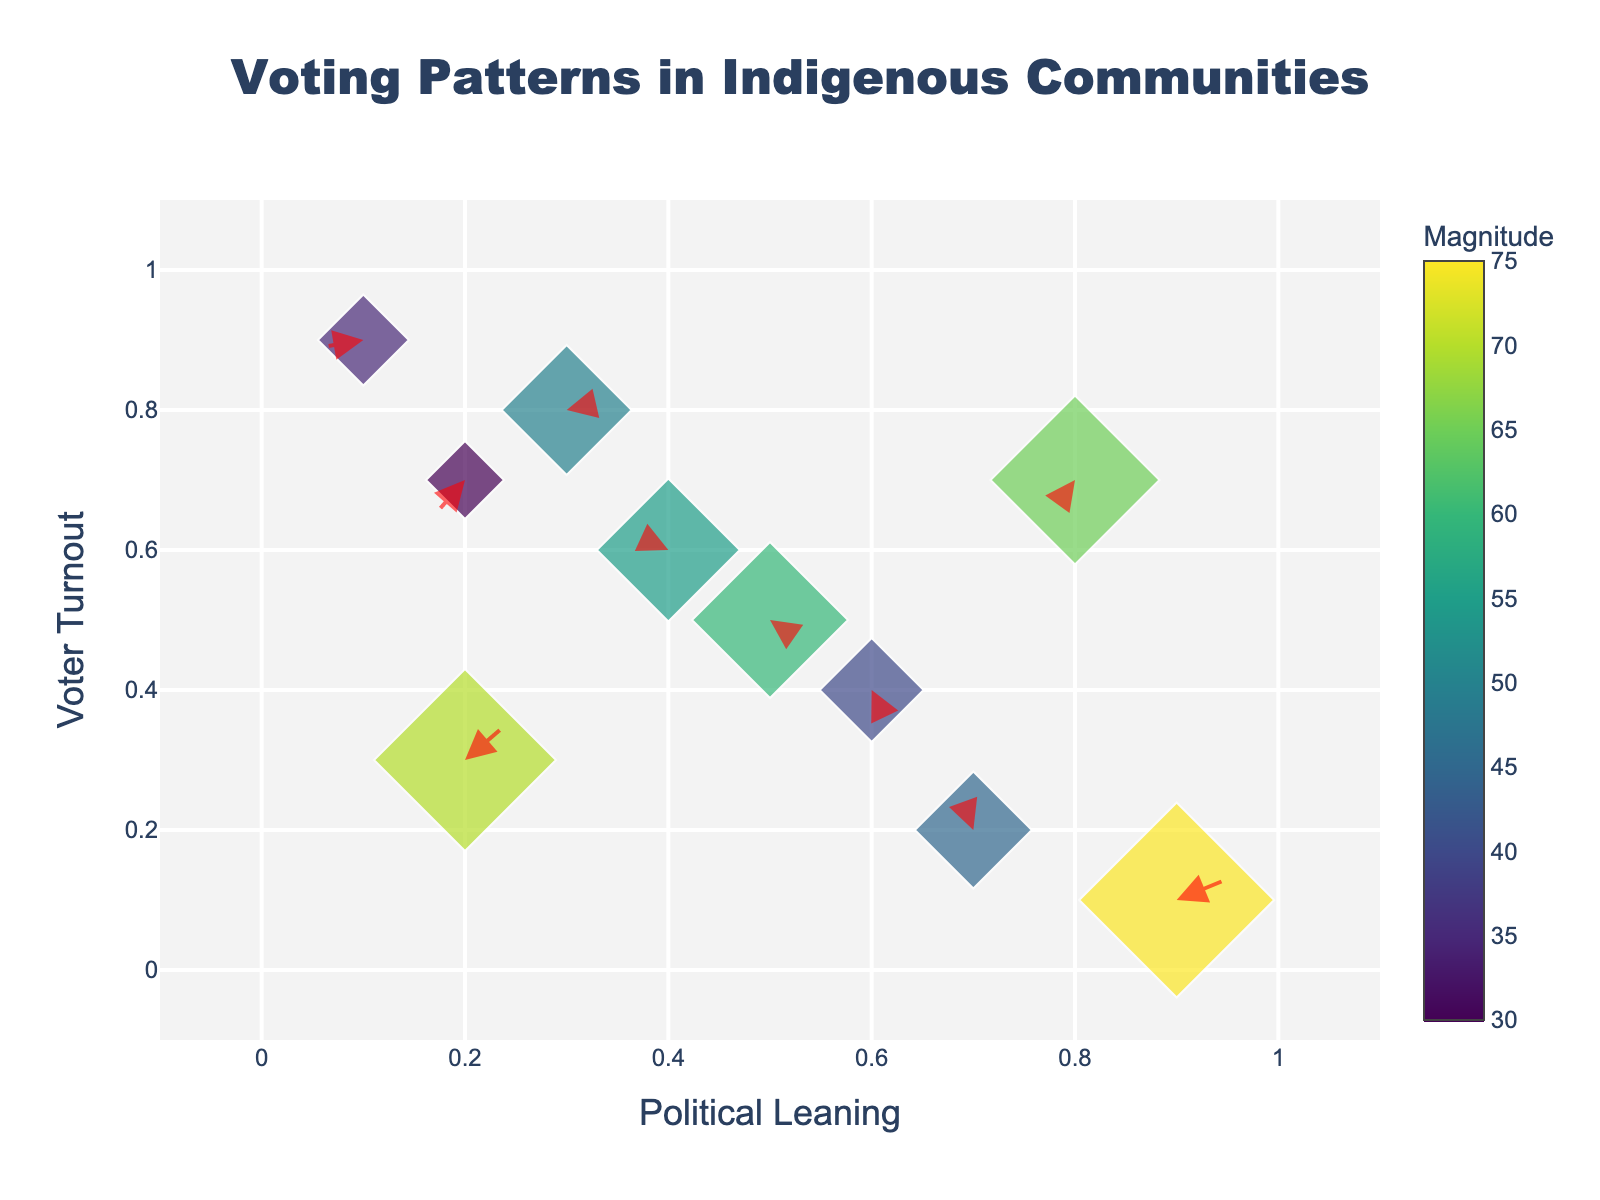How many data points are shown in the figure? The figure shows markers, and each marker represents a data point on the quiver plot. Counting the markers gives the total number of data points.
Answer: 10 What does the color of the markers represent? The color scale displayed on the figure defines the meaning of the colors. Each marker's color indicates its associated magnitude value. The attached color bar provides this information.
Answer: Magnitude What are the axes labeled? The figure title and axis labels directly give this information. The X-axis label is "Political Leaning," and the Y-axis label is "Voter Turnout."
Answer: Political Leaning and Voter Turnout Which data point has the highest magnitude? By looking at the color and size of the markers, and the values when hovering over the markers, the point with the largest marker and darkest color is identified. The highest magnitude is 75 at (0.9, 0.1).
Answer: (0.9, 0.1) Which direction do most arrows point on average? Visually inspect which general direction the majority of arrows point (upwards, downwards, leftwards, rightwards). Most arrows point towards diverse directions, but there is a general rightward trend for a majority.
Answer: Rightward How does the voter turnout at (0.7, 0.2) compare to (0.1, 0.9)? Compare the y-coordinates of these points. Since (0.7, 0.2) has a y-coordinate of 0.2 and (0.1, 0.9) has a y-coordinate of 0.9, (0.1, 0.9) has a higher voter turnout.
Answer: (0.1, 0.9) has higher voter turnout Which data point has the smallest magnitude and where is it located? Look at the marker sizes and color to identify the smallest and least colored marker and check its coordinates. The smallest magnitude is 30 at (0.2, 0.7).
Answer: (0.2, 0.7) Are there more arrows pointing upwards or downwards? Inspect each arrow's direction and count how many point upwards versus downwards. There are mixed directions, but a visual count shows more arrows pointing downward.
Answer: Downwards What is the general trend of political leaning as voter turnout increases? Observe the direction of arrows as you move from lower to higher y values, analyzing if the arrows generally move leftwards or rightwards. The downturn is slightly rightward, indicating a trend to the right.
Answer: Slight rightward What is the political leaning for the highest voter turnout data point? Identify the data point with the highest y-coordinate, and then find its corresponding x-coordinate. The point with highest turnout (y = 0.9) is at x = 0.1.
Answer: 0.1 